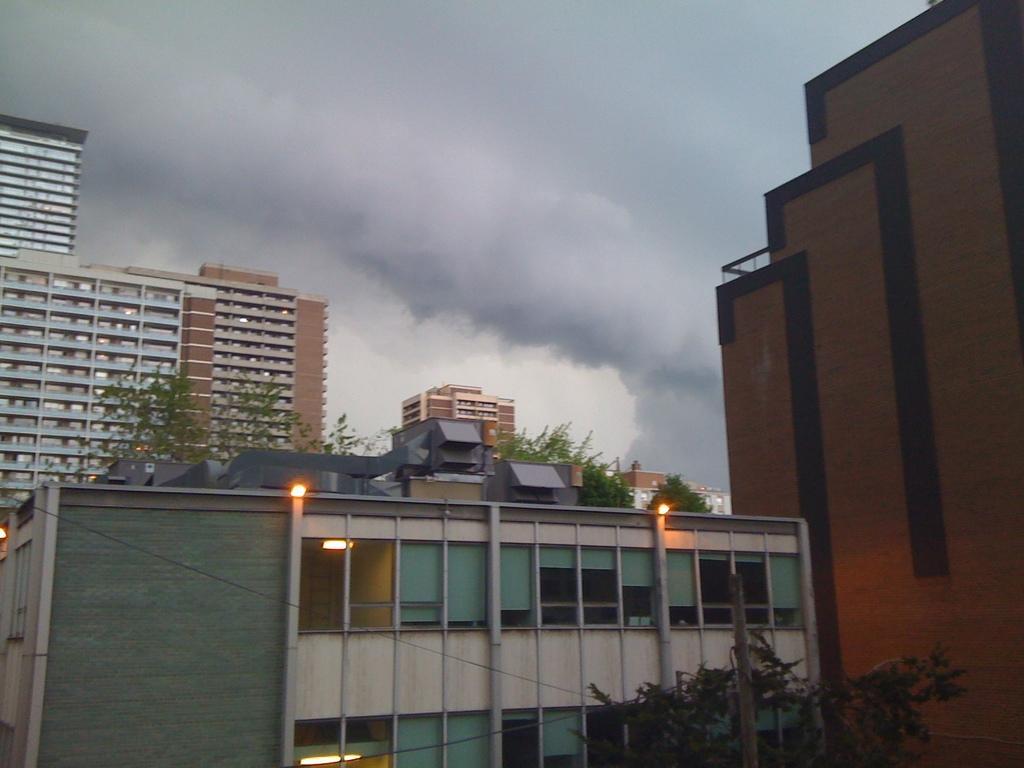Please provide a concise description of this image. In this image there are buildings. Behind the buildings there are trees. There are lights to the buildings. At the top there is the sky. 